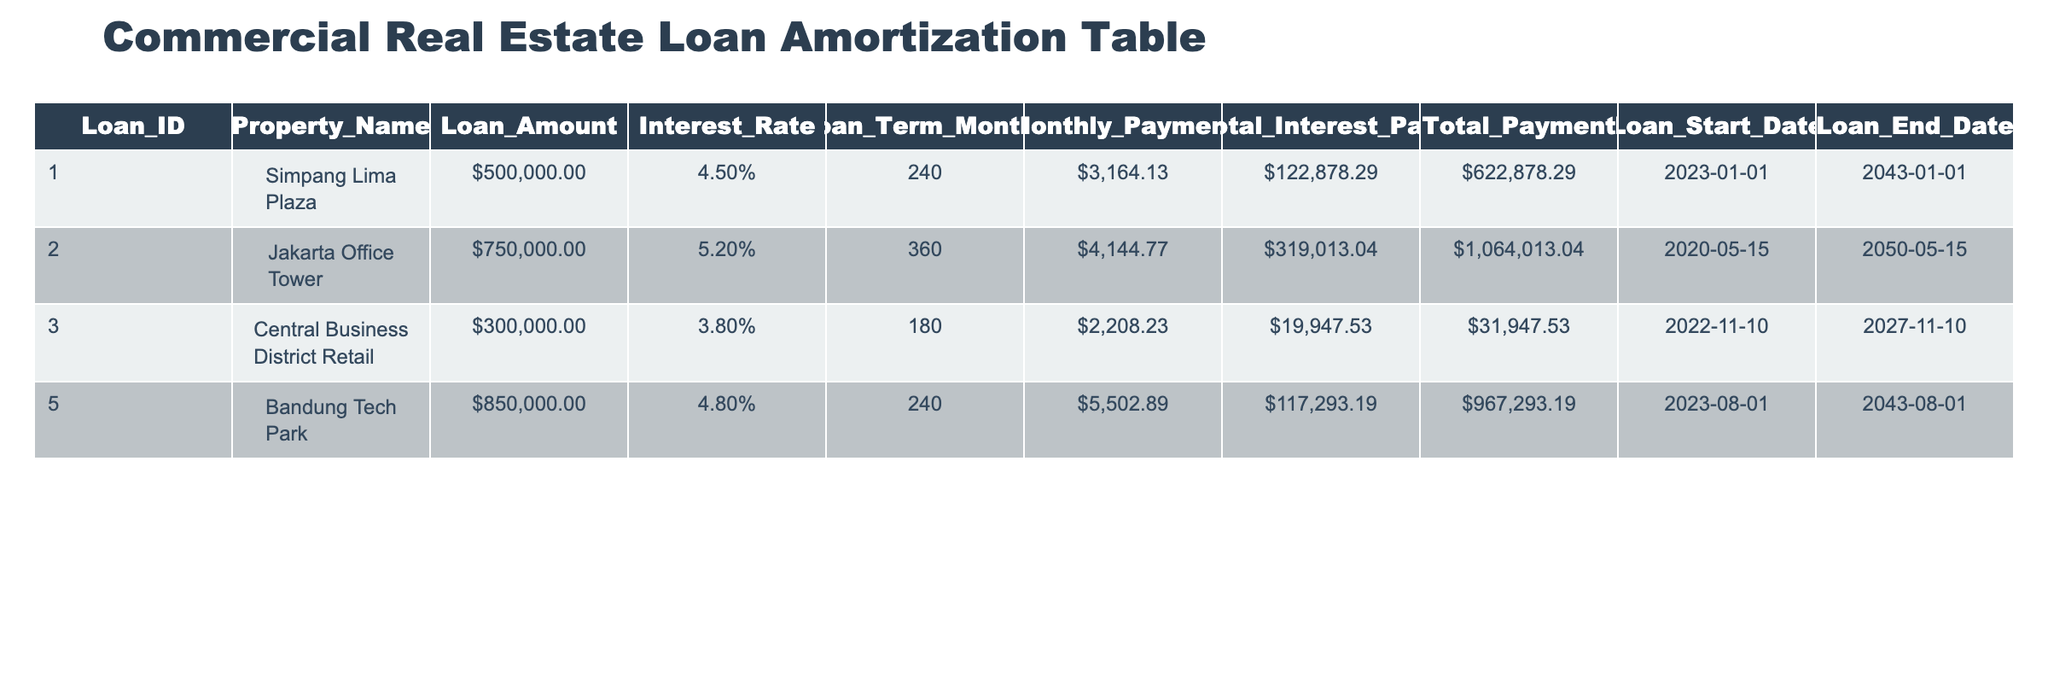What is the loan amount for the Jakarta Office Tower? According to the table, the loan amount for the Jakarta Office Tower is specified under the "Loan_Amount" column. The value is 750000.
Answer: 750000 What is the total interest paid for the loan on the Central Business District Retail property? The "Total_Interest_Paid" column shows that for the Central Business District Retail property, the total interest paid is 19947.53.
Answer: 19947.53 Which property has the highest total payment amount? By looking at the "Total_Payment" column, we can see that the Jakarta Office Tower has the highest total payment amount of 1064013.04, compared to other properties.
Answer: Jakarta Office Tower How much higher is the total interest paid for the Bandung Tech Park compared to the Central Business District Retail? We subtract the total interest paid for Central Business District Retail (19947.53) from the total interest paid for Bandung Tech Park (117293.19). The difference is 117293.19 - 19947.53 = 97245.66.
Answer: 97245.66 Is the interest rate for the Simpang Lima Plaza lower than the interest rate for the Bandung Tech Park? The interest rate for Simpang Lima Plaza is 4.5% and for Bandung Tech Park, it is 4.8%. Since 4.5% is less than 4.8%, the statement is true.
Answer: Yes What is the average loan amount across all properties? To find the average loan amount, we sum the loan amounts: 500000 + 750000 + 300000 + 850000 = 2400000. Then, we divide by the number of properties, which is 4. This gives us an average of 2400000 / 4 = 600000.
Answer: 600000 What is the total payment amount for all properties combined? The total payment is the sum of total payments for all properties: 622878.29 + 1064013.04 + 31947.53 + 967293.19 = 2002132.05.
Answer: 2002132.05 Which property has the longest loan term? The loan term for Jakarta Office Tower is 360 months, while others have 240 or 180 months. Therefore, Jakarta Office Tower has the longest loan term at 360 months.
Answer: Jakarta Office Tower For which property is the loan end date shown first among the properties? The loan end date for the Central Business District Retail is 2027-11-10, which is earlier than the end dates for all other properties.
Answer: Central Business District Retail 